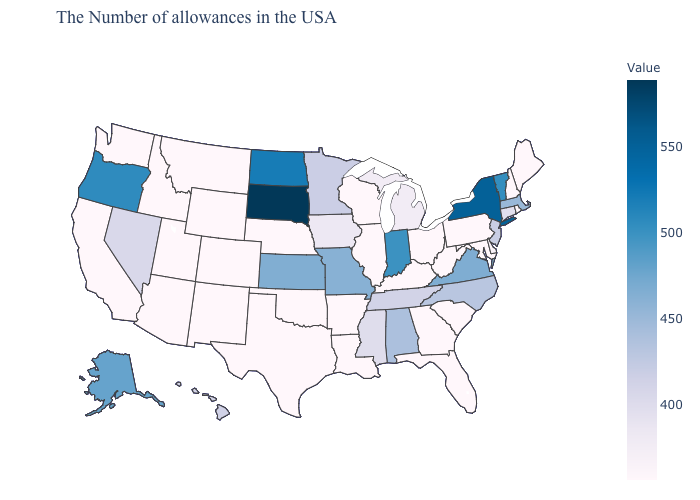Does the map have missing data?
Concise answer only. No. Does Alaska have the lowest value in the West?
Give a very brief answer. No. Among the states that border Arizona , which have the lowest value?
Keep it brief. Colorado, New Mexico, Utah, California. Does Vermont have the lowest value in the USA?
Answer briefly. No. 